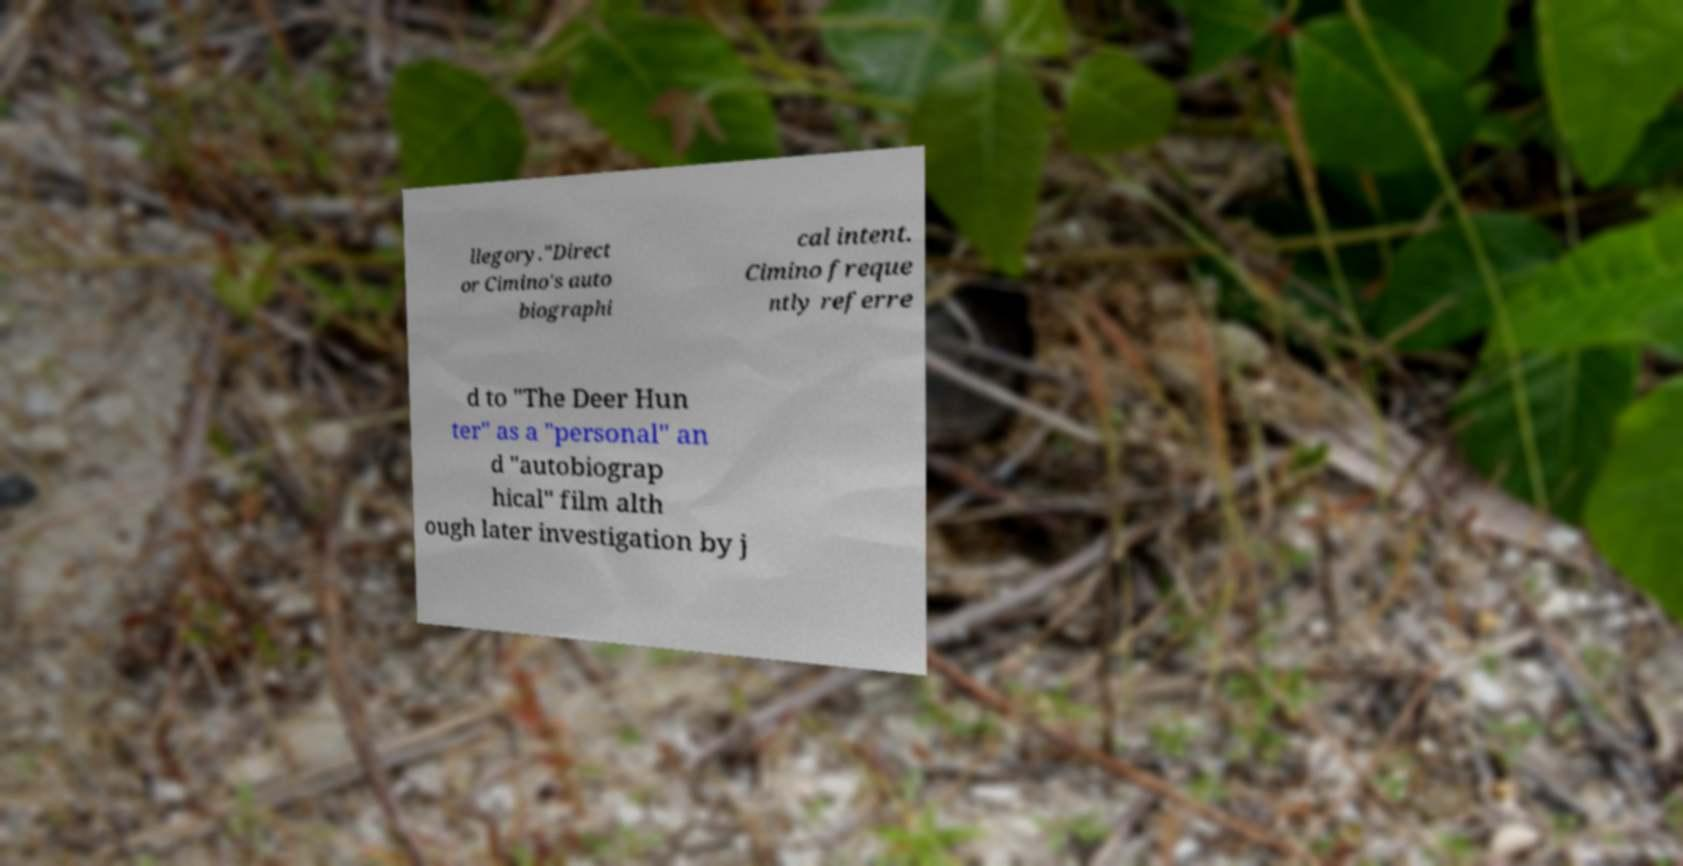For documentation purposes, I need the text within this image transcribed. Could you provide that? llegory."Direct or Cimino's auto biographi cal intent. Cimino freque ntly referre d to "The Deer Hun ter" as a "personal" an d "autobiograp hical" film alth ough later investigation by j 